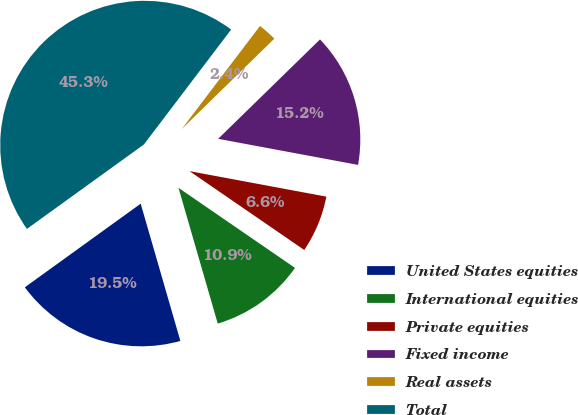<chart> <loc_0><loc_0><loc_500><loc_500><pie_chart><fcel>United States equities<fcel>International equities<fcel>Private equities<fcel>Fixed income<fcel>Real assets<fcel>Total<nl><fcel>19.53%<fcel>10.94%<fcel>6.65%<fcel>15.24%<fcel>2.36%<fcel>45.29%<nl></chart> 